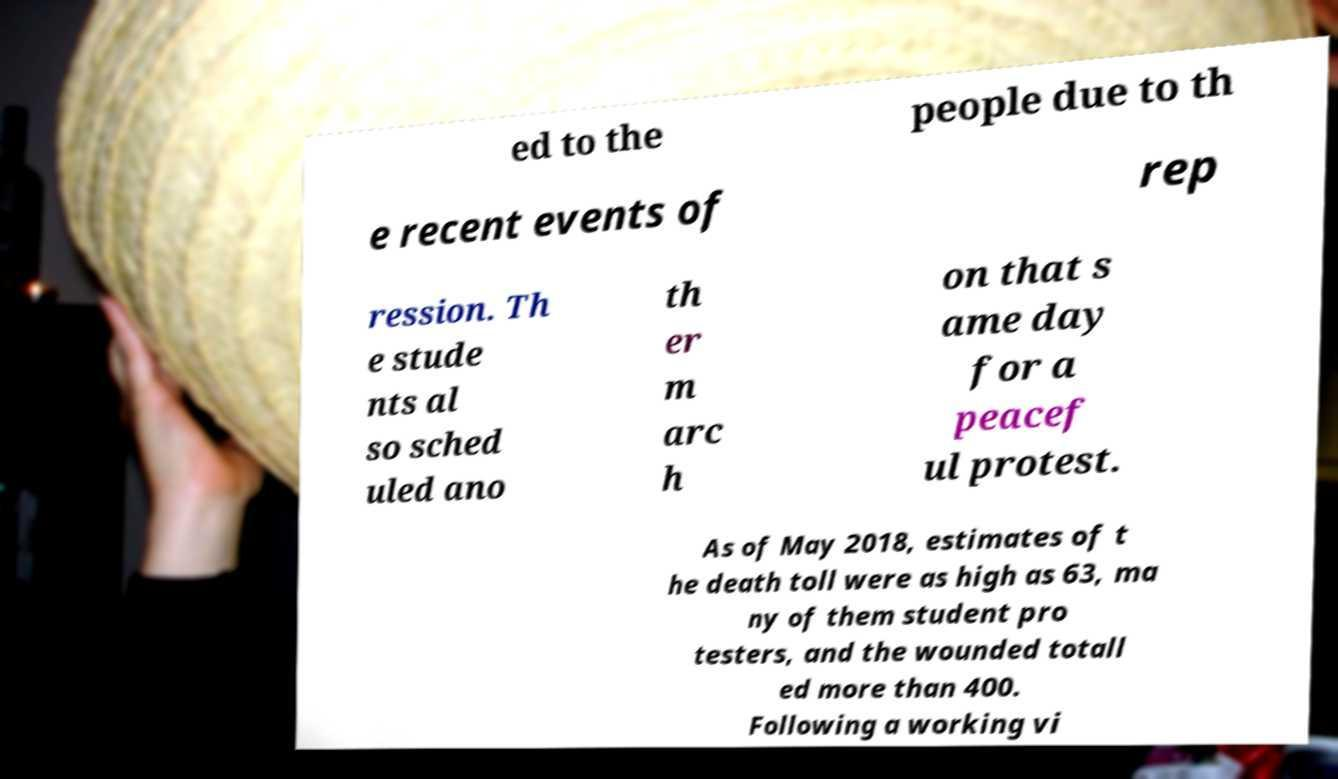Could you assist in decoding the text presented in this image and type it out clearly? ed to the people due to th e recent events of rep ression. Th e stude nts al so sched uled ano th er m arc h on that s ame day for a peacef ul protest. As of May 2018, estimates of t he death toll were as high as 63, ma ny of them student pro testers, and the wounded totall ed more than 400. Following a working vi 